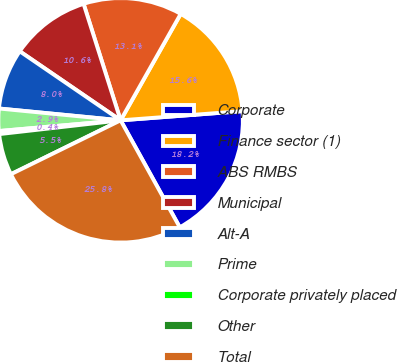Convert chart to OTSL. <chart><loc_0><loc_0><loc_500><loc_500><pie_chart><fcel>Corporate<fcel>Finance sector (1)<fcel>ABS RMBS<fcel>Municipal<fcel>Alt-A<fcel>Prime<fcel>Corporate privately placed<fcel>Other<fcel>Total<nl><fcel>18.16%<fcel>15.62%<fcel>13.08%<fcel>10.55%<fcel>8.01%<fcel>2.94%<fcel>0.4%<fcel>5.47%<fcel>25.77%<nl></chart> 